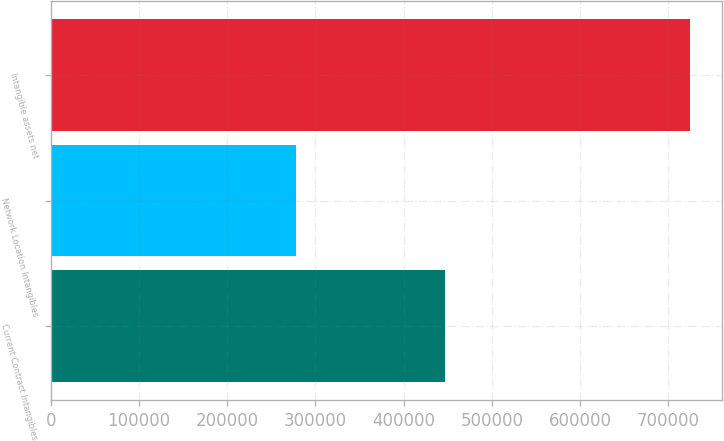Convert chart to OTSL. <chart><loc_0><loc_0><loc_500><loc_500><bar_chart><fcel>Current Contract Intangibles<fcel>Network Location Intangibles<fcel>Intangible assets net<nl><fcel>447156<fcel>277716<fcel>724872<nl></chart> 